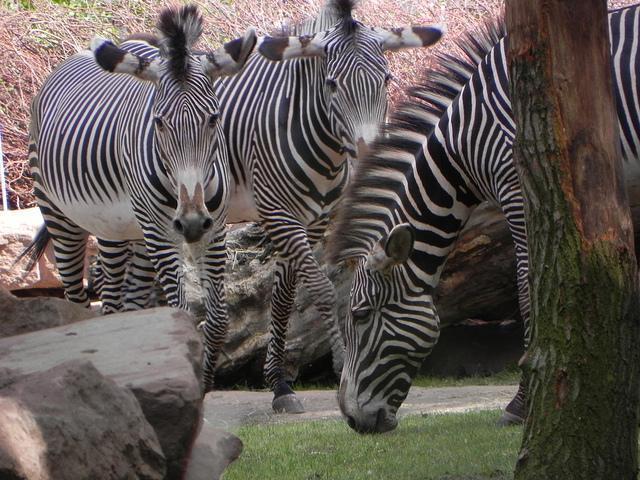How many zebras are there?
Give a very brief answer. 3. How many zebra are there?
Give a very brief answer. 3. How many zebras are looking at the camera?
Give a very brief answer. 2. How many animals are there?
Give a very brief answer. 3. How many zebras?
Give a very brief answer. 3. How many zebras are pictured?
Give a very brief answer. 3. How many zebras are in the photo?
Give a very brief answer. 3. 